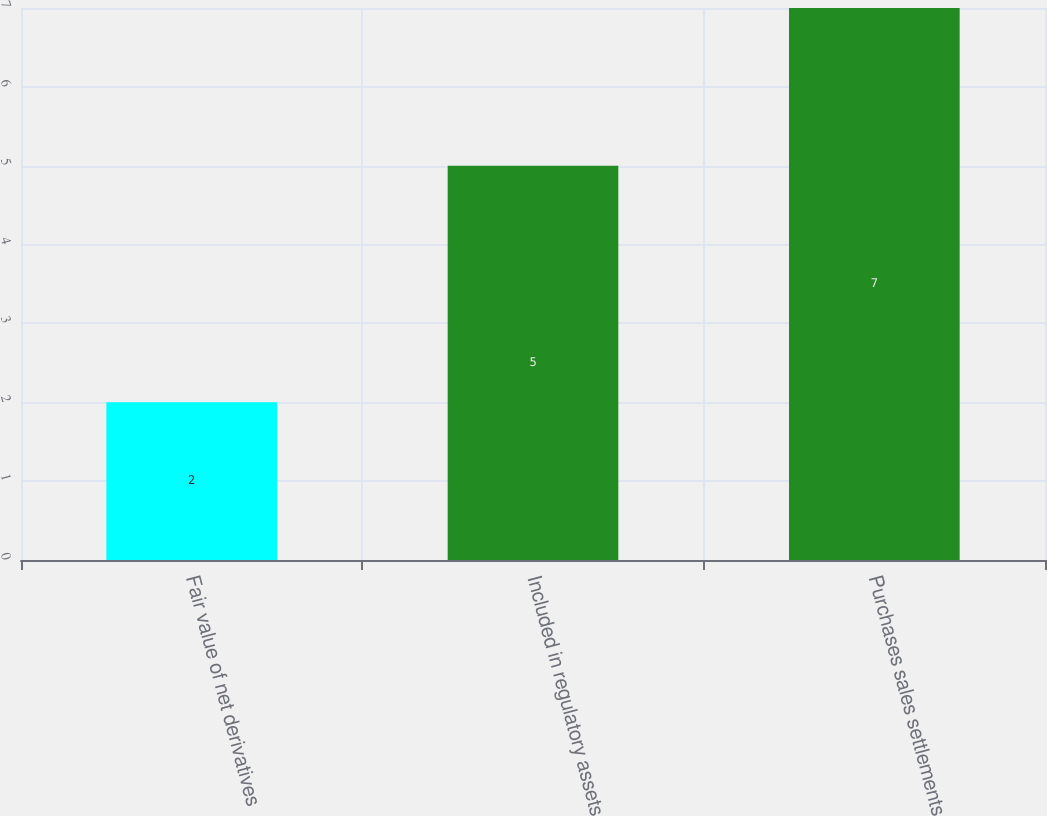Convert chart. <chart><loc_0><loc_0><loc_500><loc_500><bar_chart><fcel>Fair value of net derivatives<fcel>Included in regulatory assets<fcel>Purchases sales settlements<nl><fcel>2<fcel>5<fcel>7<nl></chart> 